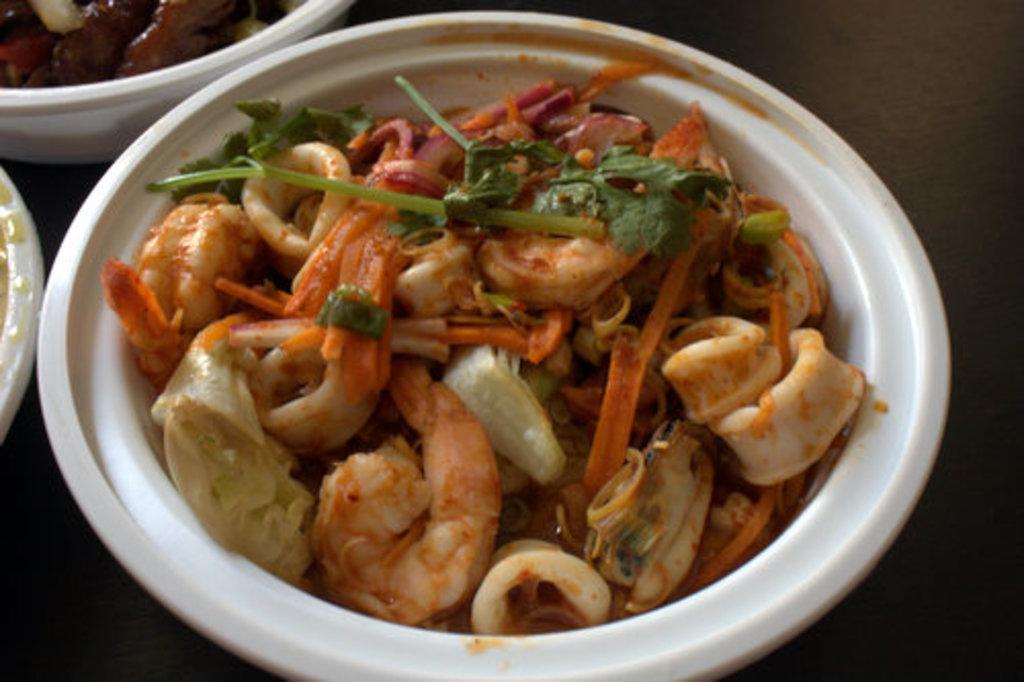In one or two sentences, can you explain what this image depicts? In this image we can see food item in a white color bowl. Top left of the image another food is there on the white bowl. 